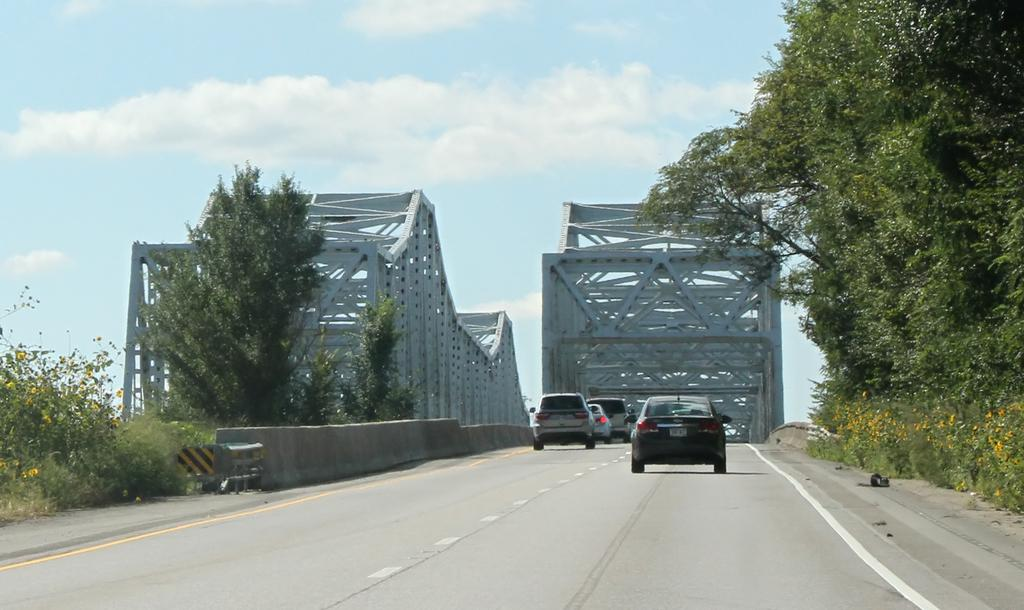What can be seen on the road in the image? There are vehicles on the road in the image. What is located beside the road in the image? There is a wall beside the road in the image. What type of vegetation is present in the image? There are trees in the image. What type of barrier can be seen in the image? There is an iron railing in the image. What is visible in the background of the image? The sky is visible in the background of the image. Where is the kettle located in the image? There is no kettle present in the image. What type of store can be seen in the image? There is no store present in the image. 